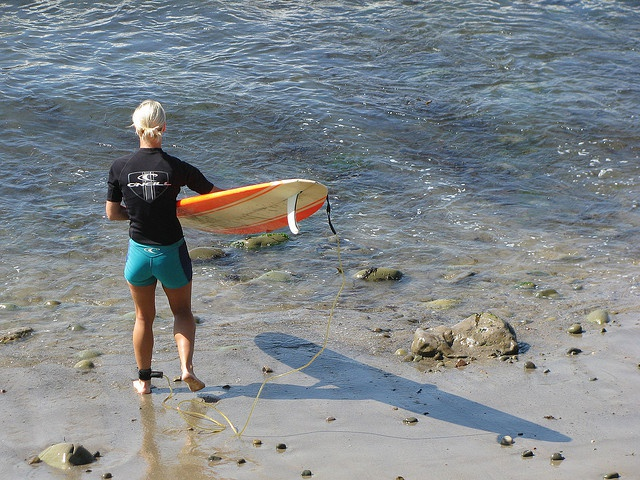Describe the objects in this image and their specific colors. I can see people in gray, black, maroon, and darkgray tones and surfboard in gray, tan, and brown tones in this image. 